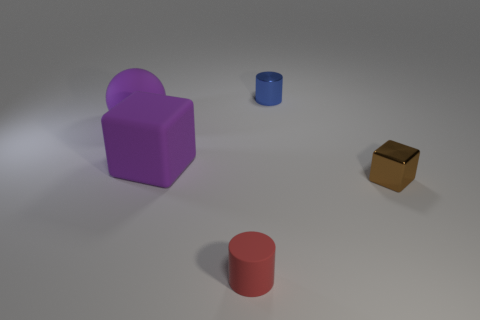Add 3 large rubber blocks. How many objects exist? 8 Subtract all red cylinders. How many cylinders are left? 1 Subtract 1 blocks. How many blocks are left? 1 Subtract all yellow blocks. How many blue cylinders are left? 1 Subtract all large purple matte spheres. Subtract all purple things. How many objects are left? 2 Add 5 purple balls. How many purple balls are left? 6 Add 2 small shiny cylinders. How many small shiny cylinders exist? 3 Subtract 0 cyan cylinders. How many objects are left? 5 Subtract all spheres. How many objects are left? 4 Subtract all gray cubes. Subtract all cyan cylinders. How many cubes are left? 2 